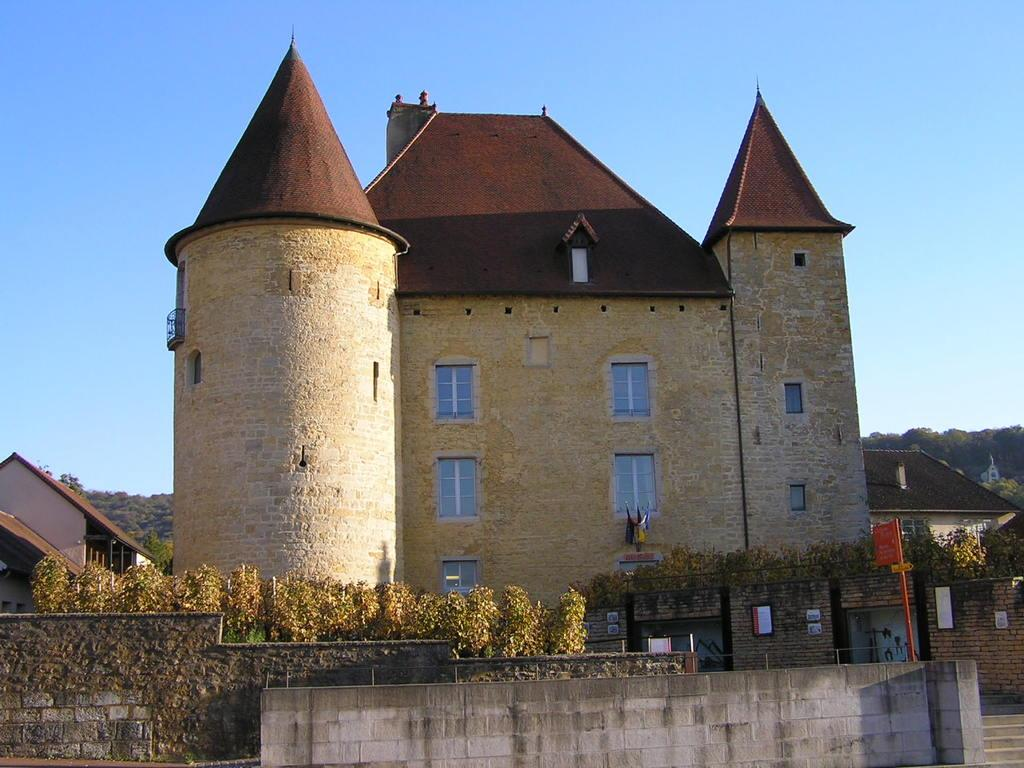What type of structures can be seen in the image? There are buildings in the image. What type of vegetation is present in the image? There are trees in the image. What are the boards attached to in the image? The boards are attached to walls in the image. What type of vertical structures can be seen in the image? There are poles in the image. What part of the natural environment is visible in the image? The sky is visible in the image. Can you tell me how many cakes are being sold at the farm in the image? There is no farm or cakes present in the image. Is your uncle visible in the image? There is no reference to an uncle in the image, so it is not possible to determine if he is present. 